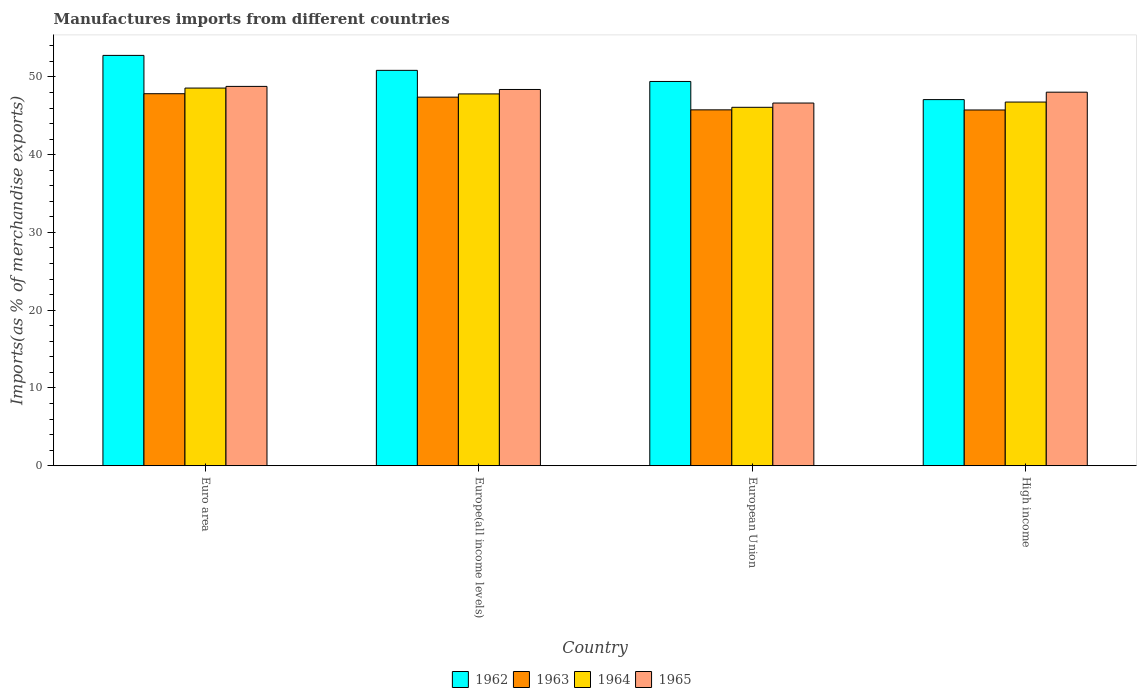How many different coloured bars are there?
Your answer should be compact. 4. How many groups of bars are there?
Your response must be concise. 4. Are the number of bars per tick equal to the number of legend labels?
Offer a very short reply. Yes. Are the number of bars on each tick of the X-axis equal?
Make the answer very short. Yes. How many bars are there on the 4th tick from the right?
Your response must be concise. 4. What is the label of the 1st group of bars from the left?
Offer a very short reply. Euro area. In how many cases, is the number of bars for a given country not equal to the number of legend labels?
Your answer should be compact. 0. What is the percentage of imports to different countries in 1963 in Euro area?
Your answer should be very brief. 47.84. Across all countries, what is the maximum percentage of imports to different countries in 1963?
Your answer should be very brief. 47.84. Across all countries, what is the minimum percentage of imports to different countries in 1962?
Give a very brief answer. 47.08. In which country was the percentage of imports to different countries in 1962 maximum?
Provide a short and direct response. Euro area. In which country was the percentage of imports to different countries in 1964 minimum?
Offer a terse response. European Union. What is the total percentage of imports to different countries in 1965 in the graph?
Your answer should be compact. 191.83. What is the difference between the percentage of imports to different countries in 1962 in European Union and that in High income?
Keep it short and to the point. 2.33. What is the difference between the percentage of imports to different countries in 1965 in High income and the percentage of imports to different countries in 1964 in Euro area?
Provide a succinct answer. -0.53. What is the average percentage of imports to different countries in 1964 per country?
Keep it short and to the point. 47.31. What is the difference between the percentage of imports to different countries of/in 1965 and percentage of imports to different countries of/in 1963 in High income?
Keep it short and to the point. 2.29. What is the ratio of the percentage of imports to different countries in 1963 in European Union to that in High income?
Ensure brevity in your answer.  1. What is the difference between the highest and the second highest percentage of imports to different countries in 1965?
Provide a short and direct response. 0.4. What is the difference between the highest and the lowest percentage of imports to different countries in 1965?
Provide a succinct answer. 2.14. Is the sum of the percentage of imports to different countries in 1965 in Euro area and High income greater than the maximum percentage of imports to different countries in 1963 across all countries?
Your answer should be very brief. Yes. Is it the case that in every country, the sum of the percentage of imports to different countries in 1964 and percentage of imports to different countries in 1963 is greater than the sum of percentage of imports to different countries in 1965 and percentage of imports to different countries in 1962?
Provide a succinct answer. Yes. What does the 4th bar from the left in European Union represents?
Provide a short and direct response. 1965. What does the 1st bar from the right in European Union represents?
Your answer should be very brief. 1965. How many bars are there?
Ensure brevity in your answer.  16. Are all the bars in the graph horizontal?
Give a very brief answer. No. What is the difference between two consecutive major ticks on the Y-axis?
Your answer should be compact. 10. Does the graph contain any zero values?
Offer a very short reply. No. Does the graph contain grids?
Offer a terse response. No. What is the title of the graph?
Provide a succinct answer. Manufactures imports from different countries. What is the label or title of the X-axis?
Give a very brief answer. Country. What is the label or title of the Y-axis?
Ensure brevity in your answer.  Imports(as % of merchandise exports). What is the Imports(as % of merchandise exports) in 1962 in Euro area?
Your answer should be compact. 52.77. What is the Imports(as % of merchandise exports) of 1963 in Euro area?
Give a very brief answer. 47.84. What is the Imports(as % of merchandise exports) of 1964 in Euro area?
Provide a succinct answer. 48.56. What is the Imports(as % of merchandise exports) in 1965 in Euro area?
Your answer should be very brief. 48.78. What is the Imports(as % of merchandise exports) in 1962 in Europe(all income levels)?
Your answer should be very brief. 50.84. What is the Imports(as % of merchandise exports) in 1963 in Europe(all income levels)?
Provide a short and direct response. 47.4. What is the Imports(as % of merchandise exports) of 1964 in Europe(all income levels)?
Your response must be concise. 47.81. What is the Imports(as % of merchandise exports) of 1965 in Europe(all income levels)?
Your answer should be compact. 48.38. What is the Imports(as % of merchandise exports) in 1962 in European Union?
Your answer should be very brief. 49.41. What is the Imports(as % of merchandise exports) in 1963 in European Union?
Provide a short and direct response. 45.76. What is the Imports(as % of merchandise exports) of 1964 in European Union?
Your answer should be compact. 46.09. What is the Imports(as % of merchandise exports) in 1965 in European Union?
Your answer should be very brief. 46.64. What is the Imports(as % of merchandise exports) in 1962 in High income?
Ensure brevity in your answer.  47.08. What is the Imports(as % of merchandise exports) in 1963 in High income?
Offer a very short reply. 45.75. What is the Imports(as % of merchandise exports) of 1964 in High income?
Offer a terse response. 46.77. What is the Imports(as % of merchandise exports) of 1965 in High income?
Your answer should be compact. 48.04. Across all countries, what is the maximum Imports(as % of merchandise exports) in 1962?
Keep it short and to the point. 52.77. Across all countries, what is the maximum Imports(as % of merchandise exports) in 1963?
Provide a short and direct response. 47.84. Across all countries, what is the maximum Imports(as % of merchandise exports) of 1964?
Offer a terse response. 48.56. Across all countries, what is the maximum Imports(as % of merchandise exports) of 1965?
Keep it short and to the point. 48.78. Across all countries, what is the minimum Imports(as % of merchandise exports) of 1962?
Provide a short and direct response. 47.08. Across all countries, what is the minimum Imports(as % of merchandise exports) of 1963?
Provide a succinct answer. 45.75. Across all countries, what is the minimum Imports(as % of merchandise exports) of 1964?
Your answer should be compact. 46.09. Across all countries, what is the minimum Imports(as % of merchandise exports) in 1965?
Ensure brevity in your answer.  46.64. What is the total Imports(as % of merchandise exports) in 1962 in the graph?
Your response must be concise. 200.1. What is the total Imports(as % of merchandise exports) in 1963 in the graph?
Give a very brief answer. 186.74. What is the total Imports(as % of merchandise exports) in 1964 in the graph?
Offer a terse response. 189.23. What is the total Imports(as % of merchandise exports) of 1965 in the graph?
Your response must be concise. 191.83. What is the difference between the Imports(as % of merchandise exports) in 1962 in Euro area and that in Europe(all income levels)?
Your answer should be very brief. 1.92. What is the difference between the Imports(as % of merchandise exports) of 1963 in Euro area and that in Europe(all income levels)?
Provide a succinct answer. 0.44. What is the difference between the Imports(as % of merchandise exports) in 1965 in Euro area and that in Europe(all income levels)?
Provide a short and direct response. 0.4. What is the difference between the Imports(as % of merchandise exports) in 1962 in Euro area and that in European Union?
Provide a short and direct response. 3.35. What is the difference between the Imports(as % of merchandise exports) of 1963 in Euro area and that in European Union?
Offer a very short reply. 2.08. What is the difference between the Imports(as % of merchandise exports) of 1964 in Euro area and that in European Union?
Ensure brevity in your answer.  2.47. What is the difference between the Imports(as % of merchandise exports) in 1965 in Euro area and that in European Union?
Give a very brief answer. 2.14. What is the difference between the Imports(as % of merchandise exports) of 1962 in Euro area and that in High income?
Offer a very short reply. 5.69. What is the difference between the Imports(as % of merchandise exports) in 1963 in Euro area and that in High income?
Offer a very short reply. 2.09. What is the difference between the Imports(as % of merchandise exports) in 1964 in Euro area and that in High income?
Your answer should be compact. 1.8. What is the difference between the Imports(as % of merchandise exports) in 1965 in Euro area and that in High income?
Offer a very short reply. 0.74. What is the difference between the Imports(as % of merchandise exports) of 1962 in Europe(all income levels) and that in European Union?
Make the answer very short. 1.43. What is the difference between the Imports(as % of merchandise exports) in 1963 in Europe(all income levels) and that in European Union?
Your response must be concise. 1.63. What is the difference between the Imports(as % of merchandise exports) in 1964 in Europe(all income levels) and that in European Union?
Offer a terse response. 1.72. What is the difference between the Imports(as % of merchandise exports) of 1965 in Europe(all income levels) and that in European Union?
Ensure brevity in your answer.  1.74. What is the difference between the Imports(as % of merchandise exports) in 1962 in Europe(all income levels) and that in High income?
Make the answer very short. 3.76. What is the difference between the Imports(as % of merchandise exports) in 1963 in Europe(all income levels) and that in High income?
Make the answer very short. 1.65. What is the difference between the Imports(as % of merchandise exports) in 1964 in Europe(all income levels) and that in High income?
Your response must be concise. 1.05. What is the difference between the Imports(as % of merchandise exports) in 1965 in Europe(all income levels) and that in High income?
Offer a very short reply. 0.35. What is the difference between the Imports(as % of merchandise exports) of 1962 in European Union and that in High income?
Ensure brevity in your answer.  2.33. What is the difference between the Imports(as % of merchandise exports) of 1963 in European Union and that in High income?
Offer a terse response. 0.02. What is the difference between the Imports(as % of merchandise exports) of 1964 in European Union and that in High income?
Your response must be concise. -0.68. What is the difference between the Imports(as % of merchandise exports) in 1965 in European Union and that in High income?
Offer a terse response. -1.4. What is the difference between the Imports(as % of merchandise exports) in 1962 in Euro area and the Imports(as % of merchandise exports) in 1963 in Europe(all income levels)?
Your answer should be compact. 5.37. What is the difference between the Imports(as % of merchandise exports) in 1962 in Euro area and the Imports(as % of merchandise exports) in 1964 in Europe(all income levels)?
Offer a terse response. 4.95. What is the difference between the Imports(as % of merchandise exports) in 1962 in Euro area and the Imports(as % of merchandise exports) in 1965 in Europe(all income levels)?
Make the answer very short. 4.38. What is the difference between the Imports(as % of merchandise exports) in 1963 in Euro area and the Imports(as % of merchandise exports) in 1964 in Europe(all income levels)?
Offer a terse response. 0.02. What is the difference between the Imports(as % of merchandise exports) in 1963 in Euro area and the Imports(as % of merchandise exports) in 1965 in Europe(all income levels)?
Provide a short and direct response. -0.54. What is the difference between the Imports(as % of merchandise exports) in 1964 in Euro area and the Imports(as % of merchandise exports) in 1965 in Europe(all income levels)?
Your answer should be very brief. 0.18. What is the difference between the Imports(as % of merchandise exports) of 1962 in Euro area and the Imports(as % of merchandise exports) of 1963 in European Union?
Ensure brevity in your answer.  7. What is the difference between the Imports(as % of merchandise exports) in 1962 in Euro area and the Imports(as % of merchandise exports) in 1964 in European Union?
Your answer should be very brief. 6.68. What is the difference between the Imports(as % of merchandise exports) of 1962 in Euro area and the Imports(as % of merchandise exports) of 1965 in European Union?
Offer a terse response. 6.13. What is the difference between the Imports(as % of merchandise exports) in 1963 in Euro area and the Imports(as % of merchandise exports) in 1964 in European Union?
Your response must be concise. 1.75. What is the difference between the Imports(as % of merchandise exports) of 1963 in Euro area and the Imports(as % of merchandise exports) of 1965 in European Union?
Keep it short and to the point. 1.2. What is the difference between the Imports(as % of merchandise exports) of 1964 in Euro area and the Imports(as % of merchandise exports) of 1965 in European Union?
Provide a succinct answer. 1.93. What is the difference between the Imports(as % of merchandise exports) of 1962 in Euro area and the Imports(as % of merchandise exports) of 1963 in High income?
Provide a succinct answer. 7.02. What is the difference between the Imports(as % of merchandise exports) in 1962 in Euro area and the Imports(as % of merchandise exports) in 1964 in High income?
Provide a short and direct response. 6. What is the difference between the Imports(as % of merchandise exports) of 1962 in Euro area and the Imports(as % of merchandise exports) of 1965 in High income?
Offer a terse response. 4.73. What is the difference between the Imports(as % of merchandise exports) in 1963 in Euro area and the Imports(as % of merchandise exports) in 1964 in High income?
Your answer should be compact. 1.07. What is the difference between the Imports(as % of merchandise exports) of 1963 in Euro area and the Imports(as % of merchandise exports) of 1965 in High income?
Your answer should be very brief. -0.2. What is the difference between the Imports(as % of merchandise exports) in 1964 in Euro area and the Imports(as % of merchandise exports) in 1965 in High income?
Your answer should be compact. 0.53. What is the difference between the Imports(as % of merchandise exports) of 1962 in Europe(all income levels) and the Imports(as % of merchandise exports) of 1963 in European Union?
Your answer should be compact. 5.08. What is the difference between the Imports(as % of merchandise exports) in 1962 in Europe(all income levels) and the Imports(as % of merchandise exports) in 1964 in European Union?
Provide a short and direct response. 4.75. What is the difference between the Imports(as % of merchandise exports) of 1962 in Europe(all income levels) and the Imports(as % of merchandise exports) of 1965 in European Union?
Provide a succinct answer. 4.2. What is the difference between the Imports(as % of merchandise exports) of 1963 in Europe(all income levels) and the Imports(as % of merchandise exports) of 1964 in European Union?
Your answer should be very brief. 1.31. What is the difference between the Imports(as % of merchandise exports) of 1963 in Europe(all income levels) and the Imports(as % of merchandise exports) of 1965 in European Union?
Offer a very short reply. 0.76. What is the difference between the Imports(as % of merchandise exports) of 1964 in Europe(all income levels) and the Imports(as % of merchandise exports) of 1965 in European Union?
Offer a very short reply. 1.18. What is the difference between the Imports(as % of merchandise exports) of 1962 in Europe(all income levels) and the Imports(as % of merchandise exports) of 1963 in High income?
Your response must be concise. 5.1. What is the difference between the Imports(as % of merchandise exports) in 1962 in Europe(all income levels) and the Imports(as % of merchandise exports) in 1964 in High income?
Make the answer very short. 4.08. What is the difference between the Imports(as % of merchandise exports) of 1962 in Europe(all income levels) and the Imports(as % of merchandise exports) of 1965 in High income?
Your answer should be compact. 2.81. What is the difference between the Imports(as % of merchandise exports) in 1963 in Europe(all income levels) and the Imports(as % of merchandise exports) in 1964 in High income?
Provide a short and direct response. 0.63. What is the difference between the Imports(as % of merchandise exports) in 1963 in Europe(all income levels) and the Imports(as % of merchandise exports) in 1965 in High income?
Ensure brevity in your answer.  -0.64. What is the difference between the Imports(as % of merchandise exports) in 1964 in Europe(all income levels) and the Imports(as % of merchandise exports) in 1965 in High income?
Your answer should be compact. -0.22. What is the difference between the Imports(as % of merchandise exports) in 1962 in European Union and the Imports(as % of merchandise exports) in 1963 in High income?
Make the answer very short. 3.67. What is the difference between the Imports(as % of merchandise exports) in 1962 in European Union and the Imports(as % of merchandise exports) in 1964 in High income?
Your response must be concise. 2.65. What is the difference between the Imports(as % of merchandise exports) in 1962 in European Union and the Imports(as % of merchandise exports) in 1965 in High income?
Your answer should be very brief. 1.38. What is the difference between the Imports(as % of merchandise exports) in 1963 in European Union and the Imports(as % of merchandise exports) in 1964 in High income?
Make the answer very short. -1. What is the difference between the Imports(as % of merchandise exports) of 1963 in European Union and the Imports(as % of merchandise exports) of 1965 in High income?
Ensure brevity in your answer.  -2.27. What is the difference between the Imports(as % of merchandise exports) of 1964 in European Union and the Imports(as % of merchandise exports) of 1965 in High income?
Give a very brief answer. -1.94. What is the average Imports(as % of merchandise exports) of 1962 per country?
Give a very brief answer. 50.03. What is the average Imports(as % of merchandise exports) of 1963 per country?
Keep it short and to the point. 46.69. What is the average Imports(as % of merchandise exports) in 1964 per country?
Ensure brevity in your answer.  47.31. What is the average Imports(as % of merchandise exports) of 1965 per country?
Keep it short and to the point. 47.96. What is the difference between the Imports(as % of merchandise exports) of 1962 and Imports(as % of merchandise exports) of 1963 in Euro area?
Your answer should be very brief. 4.93. What is the difference between the Imports(as % of merchandise exports) of 1962 and Imports(as % of merchandise exports) of 1964 in Euro area?
Your answer should be compact. 4.2. What is the difference between the Imports(as % of merchandise exports) in 1962 and Imports(as % of merchandise exports) in 1965 in Euro area?
Your answer should be very brief. 3.99. What is the difference between the Imports(as % of merchandise exports) of 1963 and Imports(as % of merchandise exports) of 1964 in Euro area?
Provide a short and direct response. -0.73. What is the difference between the Imports(as % of merchandise exports) in 1963 and Imports(as % of merchandise exports) in 1965 in Euro area?
Make the answer very short. -0.94. What is the difference between the Imports(as % of merchandise exports) of 1964 and Imports(as % of merchandise exports) of 1965 in Euro area?
Your response must be concise. -0.21. What is the difference between the Imports(as % of merchandise exports) of 1962 and Imports(as % of merchandise exports) of 1963 in Europe(all income levels)?
Provide a short and direct response. 3.45. What is the difference between the Imports(as % of merchandise exports) in 1962 and Imports(as % of merchandise exports) in 1964 in Europe(all income levels)?
Provide a succinct answer. 3.03. What is the difference between the Imports(as % of merchandise exports) in 1962 and Imports(as % of merchandise exports) in 1965 in Europe(all income levels)?
Your response must be concise. 2.46. What is the difference between the Imports(as % of merchandise exports) in 1963 and Imports(as % of merchandise exports) in 1964 in Europe(all income levels)?
Your response must be concise. -0.42. What is the difference between the Imports(as % of merchandise exports) of 1963 and Imports(as % of merchandise exports) of 1965 in Europe(all income levels)?
Provide a succinct answer. -0.99. What is the difference between the Imports(as % of merchandise exports) of 1964 and Imports(as % of merchandise exports) of 1965 in Europe(all income levels)?
Give a very brief answer. -0.57. What is the difference between the Imports(as % of merchandise exports) of 1962 and Imports(as % of merchandise exports) of 1963 in European Union?
Ensure brevity in your answer.  3.65. What is the difference between the Imports(as % of merchandise exports) in 1962 and Imports(as % of merchandise exports) in 1964 in European Union?
Your answer should be very brief. 3.32. What is the difference between the Imports(as % of merchandise exports) of 1962 and Imports(as % of merchandise exports) of 1965 in European Union?
Give a very brief answer. 2.78. What is the difference between the Imports(as % of merchandise exports) in 1963 and Imports(as % of merchandise exports) in 1964 in European Union?
Keep it short and to the point. -0.33. What is the difference between the Imports(as % of merchandise exports) in 1963 and Imports(as % of merchandise exports) in 1965 in European Union?
Your response must be concise. -0.88. What is the difference between the Imports(as % of merchandise exports) of 1964 and Imports(as % of merchandise exports) of 1965 in European Union?
Ensure brevity in your answer.  -0.55. What is the difference between the Imports(as % of merchandise exports) of 1962 and Imports(as % of merchandise exports) of 1963 in High income?
Your response must be concise. 1.33. What is the difference between the Imports(as % of merchandise exports) in 1962 and Imports(as % of merchandise exports) in 1964 in High income?
Your answer should be very brief. 0.31. What is the difference between the Imports(as % of merchandise exports) in 1962 and Imports(as % of merchandise exports) in 1965 in High income?
Your answer should be compact. -0.96. What is the difference between the Imports(as % of merchandise exports) of 1963 and Imports(as % of merchandise exports) of 1964 in High income?
Offer a terse response. -1.02. What is the difference between the Imports(as % of merchandise exports) of 1963 and Imports(as % of merchandise exports) of 1965 in High income?
Keep it short and to the point. -2.29. What is the difference between the Imports(as % of merchandise exports) of 1964 and Imports(as % of merchandise exports) of 1965 in High income?
Your response must be concise. -1.27. What is the ratio of the Imports(as % of merchandise exports) of 1962 in Euro area to that in Europe(all income levels)?
Your answer should be compact. 1.04. What is the ratio of the Imports(as % of merchandise exports) in 1963 in Euro area to that in Europe(all income levels)?
Provide a short and direct response. 1.01. What is the ratio of the Imports(as % of merchandise exports) in 1964 in Euro area to that in Europe(all income levels)?
Offer a very short reply. 1.02. What is the ratio of the Imports(as % of merchandise exports) in 1965 in Euro area to that in Europe(all income levels)?
Ensure brevity in your answer.  1.01. What is the ratio of the Imports(as % of merchandise exports) in 1962 in Euro area to that in European Union?
Ensure brevity in your answer.  1.07. What is the ratio of the Imports(as % of merchandise exports) of 1963 in Euro area to that in European Union?
Make the answer very short. 1.05. What is the ratio of the Imports(as % of merchandise exports) of 1964 in Euro area to that in European Union?
Offer a terse response. 1.05. What is the ratio of the Imports(as % of merchandise exports) in 1965 in Euro area to that in European Union?
Your response must be concise. 1.05. What is the ratio of the Imports(as % of merchandise exports) in 1962 in Euro area to that in High income?
Your answer should be compact. 1.12. What is the ratio of the Imports(as % of merchandise exports) in 1963 in Euro area to that in High income?
Offer a terse response. 1.05. What is the ratio of the Imports(as % of merchandise exports) in 1964 in Euro area to that in High income?
Ensure brevity in your answer.  1.04. What is the ratio of the Imports(as % of merchandise exports) of 1965 in Euro area to that in High income?
Offer a very short reply. 1.02. What is the ratio of the Imports(as % of merchandise exports) of 1962 in Europe(all income levels) to that in European Union?
Make the answer very short. 1.03. What is the ratio of the Imports(as % of merchandise exports) of 1963 in Europe(all income levels) to that in European Union?
Make the answer very short. 1.04. What is the ratio of the Imports(as % of merchandise exports) of 1964 in Europe(all income levels) to that in European Union?
Give a very brief answer. 1.04. What is the ratio of the Imports(as % of merchandise exports) in 1965 in Europe(all income levels) to that in European Union?
Your answer should be very brief. 1.04. What is the ratio of the Imports(as % of merchandise exports) in 1962 in Europe(all income levels) to that in High income?
Your answer should be compact. 1.08. What is the ratio of the Imports(as % of merchandise exports) of 1963 in Europe(all income levels) to that in High income?
Ensure brevity in your answer.  1.04. What is the ratio of the Imports(as % of merchandise exports) of 1964 in Europe(all income levels) to that in High income?
Provide a succinct answer. 1.02. What is the ratio of the Imports(as % of merchandise exports) in 1962 in European Union to that in High income?
Offer a terse response. 1.05. What is the ratio of the Imports(as % of merchandise exports) of 1964 in European Union to that in High income?
Provide a short and direct response. 0.99. What is the ratio of the Imports(as % of merchandise exports) in 1965 in European Union to that in High income?
Provide a short and direct response. 0.97. What is the difference between the highest and the second highest Imports(as % of merchandise exports) of 1962?
Offer a terse response. 1.92. What is the difference between the highest and the second highest Imports(as % of merchandise exports) in 1963?
Make the answer very short. 0.44. What is the difference between the highest and the second highest Imports(as % of merchandise exports) in 1964?
Your answer should be very brief. 0.75. What is the difference between the highest and the second highest Imports(as % of merchandise exports) of 1965?
Your response must be concise. 0.4. What is the difference between the highest and the lowest Imports(as % of merchandise exports) of 1962?
Offer a terse response. 5.69. What is the difference between the highest and the lowest Imports(as % of merchandise exports) in 1963?
Ensure brevity in your answer.  2.09. What is the difference between the highest and the lowest Imports(as % of merchandise exports) of 1964?
Your response must be concise. 2.47. What is the difference between the highest and the lowest Imports(as % of merchandise exports) in 1965?
Offer a terse response. 2.14. 